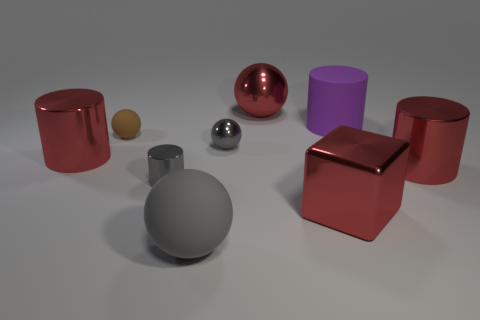What is the texture of the objects in the image? The objects in the image exhibit a variety of textures. The red objects have a smooth and reflective surface that indicates a metallic or polished finish. The large purple cylinder looks to have a matte texture, while the smaller spheres are also reflective but appear smoother and potentially more polished. 